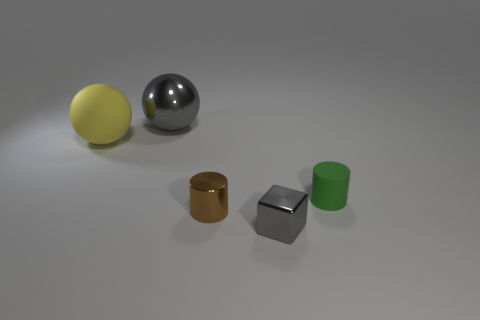Add 5 small green cylinders. How many objects exist? 10 Subtract all blocks. How many objects are left? 4 Add 1 small rubber cylinders. How many small rubber cylinders exist? 2 Subtract 0 purple spheres. How many objects are left? 5 Subtract all big gray cylinders. Subtract all large gray balls. How many objects are left? 4 Add 5 big yellow balls. How many big yellow balls are left? 6 